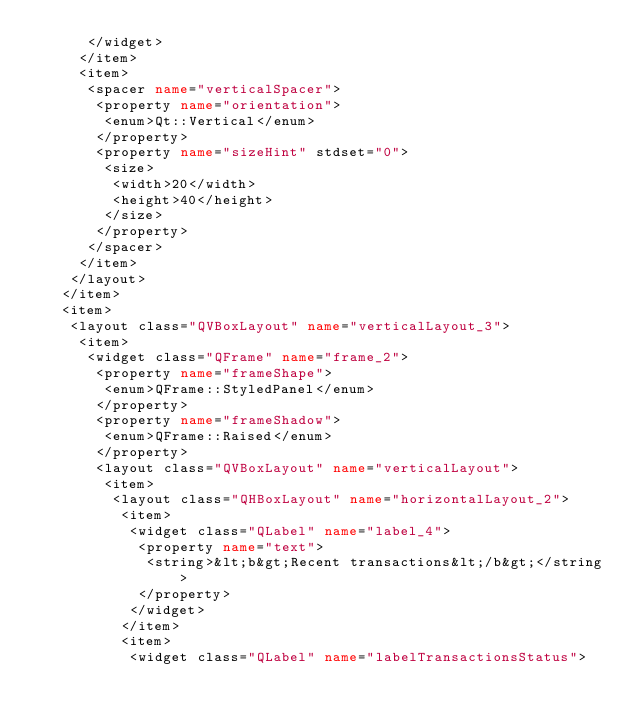<code> <loc_0><loc_0><loc_500><loc_500><_XML_>      </widget>
     </item>
     <item>
      <spacer name="verticalSpacer">
       <property name="orientation">
        <enum>Qt::Vertical</enum>
       </property>
       <property name="sizeHint" stdset="0">
        <size>
         <width>20</width>
         <height>40</height>
        </size>
       </property>
      </spacer>
     </item>
    </layout>
   </item>
   <item>
    <layout class="QVBoxLayout" name="verticalLayout_3">
     <item>
      <widget class="QFrame" name="frame_2">
       <property name="frameShape">
        <enum>QFrame::StyledPanel</enum>
       </property>
       <property name="frameShadow">
        <enum>QFrame::Raised</enum>
       </property>
       <layout class="QVBoxLayout" name="verticalLayout">
        <item>
         <layout class="QHBoxLayout" name="horizontalLayout_2">
          <item>
           <widget class="QLabel" name="label_4">
            <property name="text">
             <string>&lt;b&gt;Recent transactions&lt;/b&gt;</string>
            </property>
           </widget>
          </item>
          <item>
           <widget class="QLabel" name="labelTransactionsStatus"></code> 